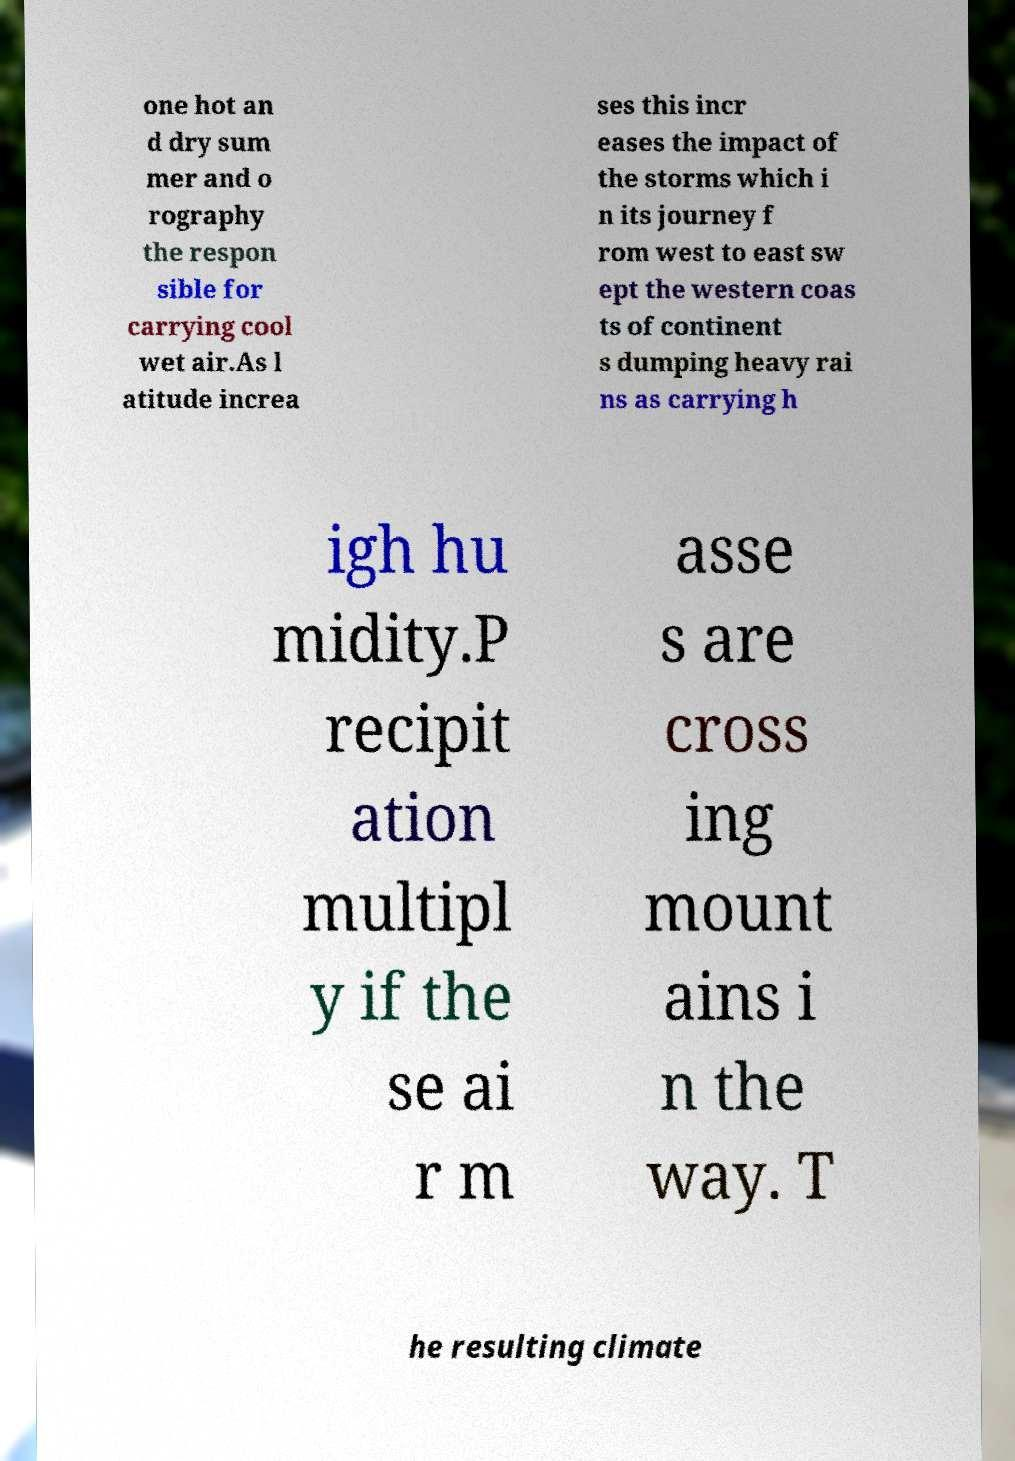What messages or text are displayed in this image? I need them in a readable, typed format. one hot an d dry sum mer and o rography the respon sible for carrying cool wet air.As l atitude increa ses this incr eases the impact of the storms which i n its journey f rom west to east sw ept the western coas ts of continent s dumping heavy rai ns as carrying h igh hu midity.P recipit ation multipl y if the se ai r m asse s are cross ing mount ains i n the way. T he resulting climate 